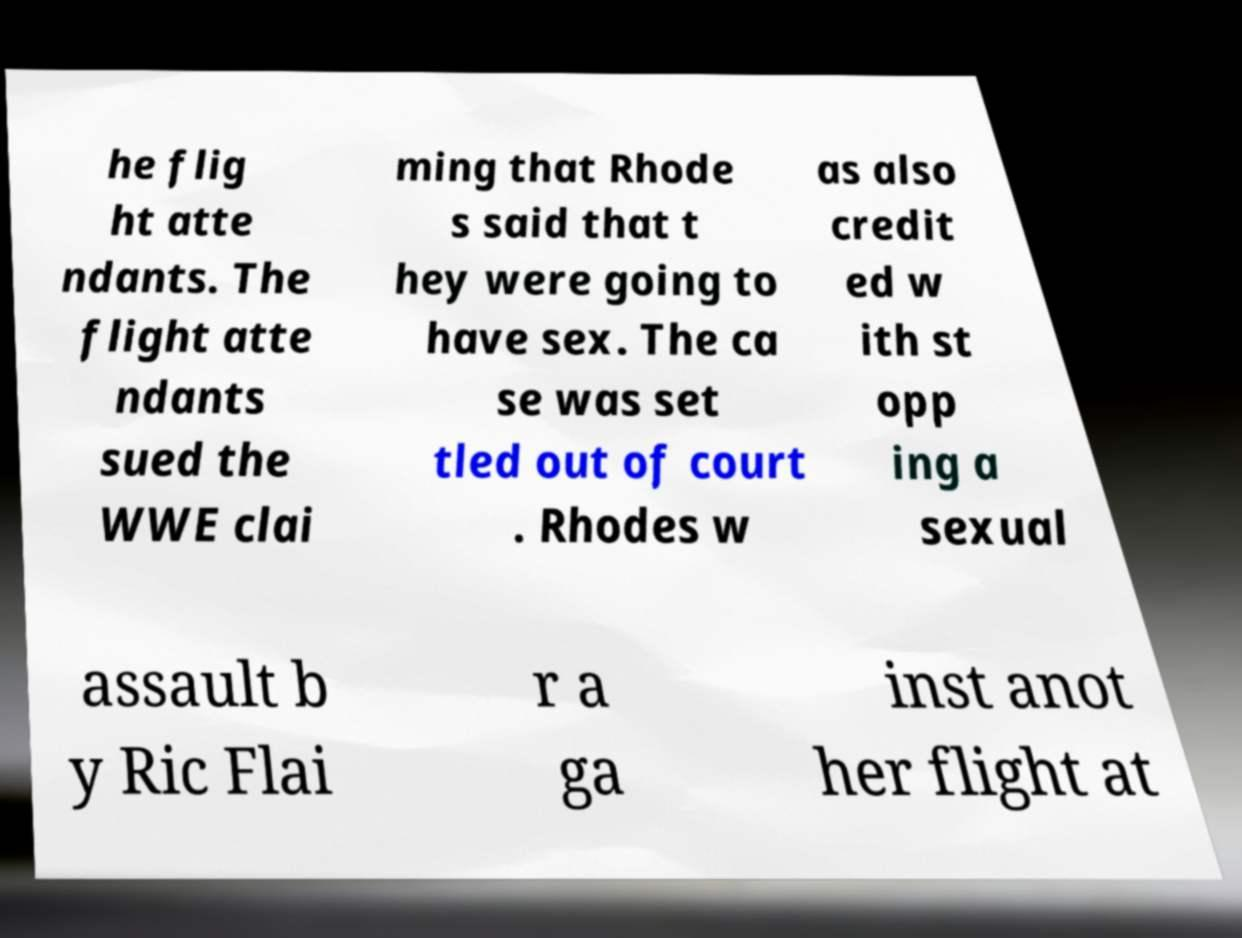Could you extract and type out the text from this image? he flig ht atte ndants. The flight atte ndants sued the WWE clai ming that Rhode s said that t hey were going to have sex. The ca se was set tled out of court . Rhodes w as also credit ed w ith st opp ing a sexual assault b y Ric Flai r a ga inst anot her flight at 